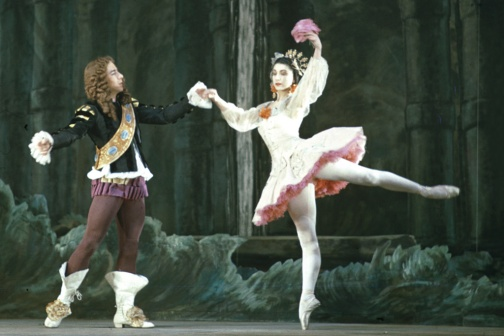Can you describe the main features of this image for me? In the midst of a setting that evokes the feel of a mystical, cavernous stage, a ballet performance unfolds with grace and elegance. At the center, a male dancer exudes regality with his royal blue and gold jacket, complemented by maroon pants and pristine white shoes. His posture, with arms reaching out, beckons his partner into the intricate dance they share.

Opposite him, a female dancer seems to defy gravity in a mid-air leap, adorned in a delicate white tutu highlighted with pink and gold details. Her leg extended behind and the other bent elegantly at the knee, she forms a striking figure of poise and beauty. Her white ballet slippers complete her ethereal appearance.

The interaction between the dancers suggests a narrative, a story expressed through their movements. The rocky, cavern-like background adds a dramatic and almost surreal ambiance to the scene, enhancing the emotional depth of the performance. This snapshot captures a fleeting, yet timeless moment of beauty and story-telling through ballet. 